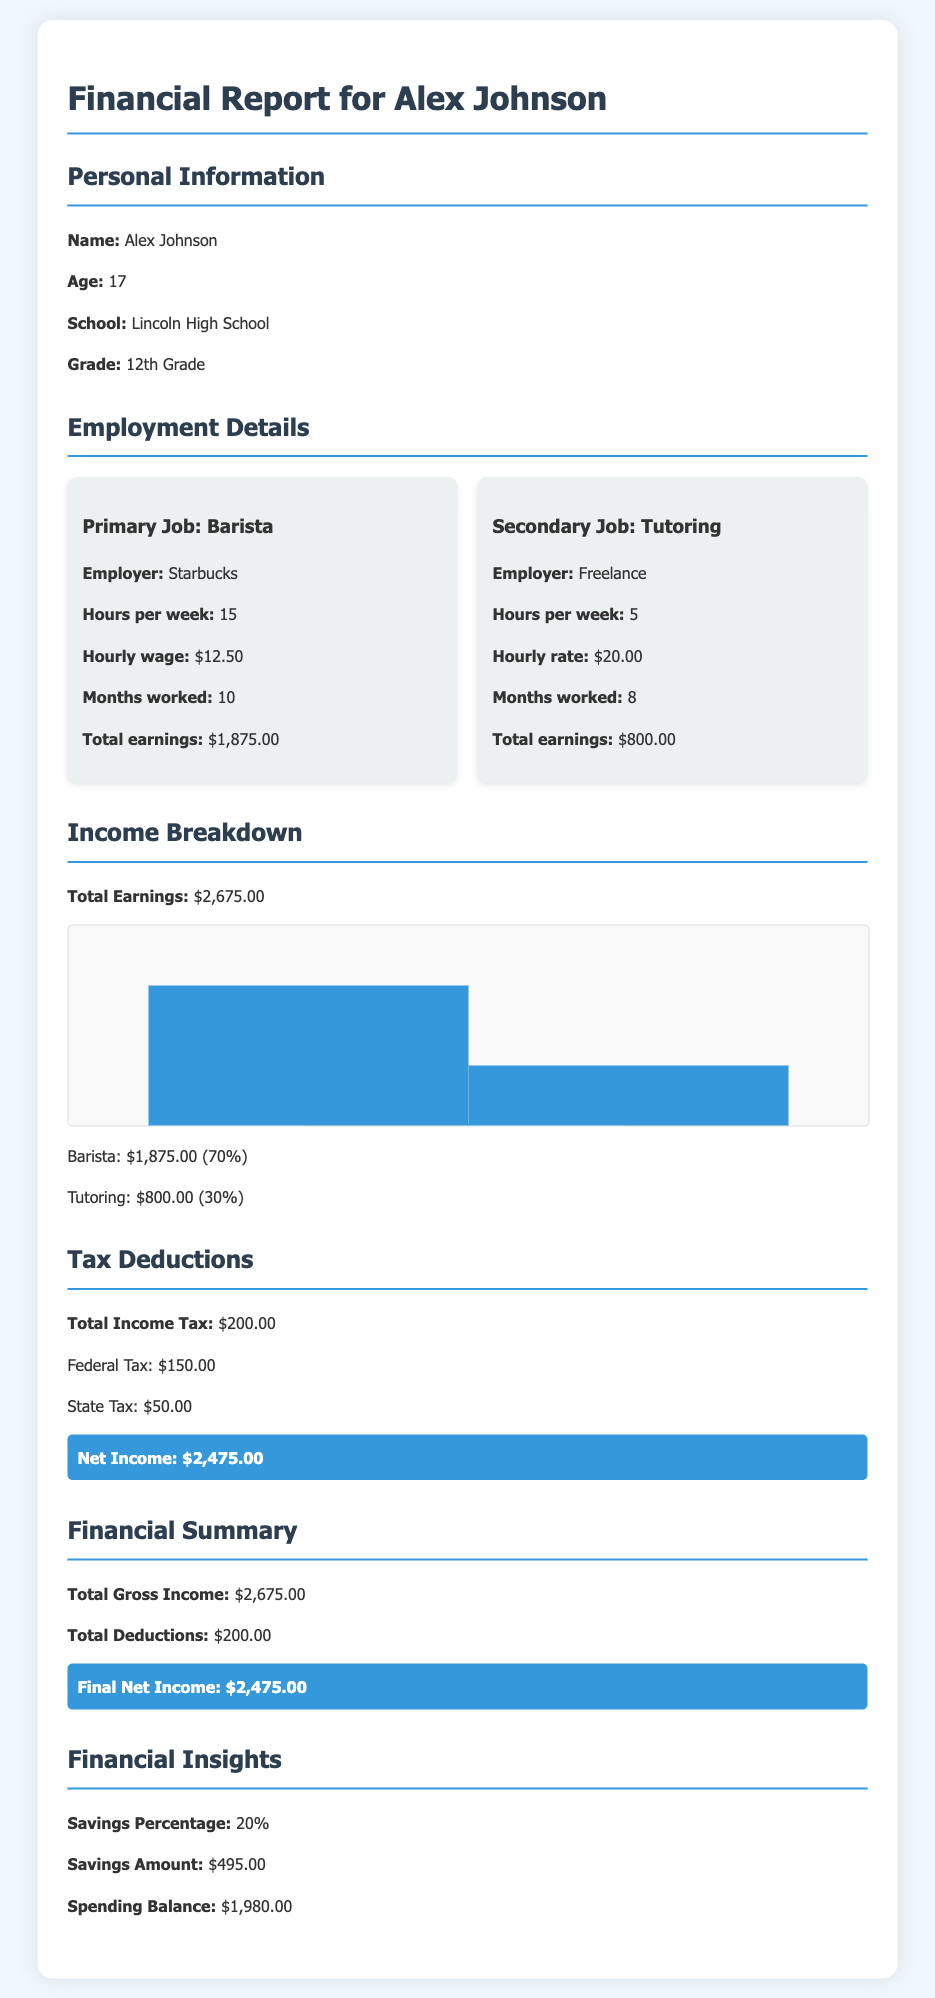What is the primary job? The primary job is identified in the document as "Barista" at Starbucks.
Answer: Barista What is the hourly wage for the primary job? The document states the hourly wage for the primary job is $12.50.
Answer: $12.50 How much did Alex earn from tutoring? The total earnings from tutoring are explicitly listed in the report as $800.00.
Answer: $800.00 What is the total income tax deducted? The total income tax is provided in the document as $200.00.
Answer: $200.00 What is the net income reported? The net income after tax deductions is highlighted in the document as $2,475.00.
Answer: $2,475.00 What percentage of total income is from the primary job? The report states that 70% of the total earnings come from the primary job, Barista.
Answer: 70% What is the total gross income? The document mentions that the total gross income is $2,675.00.
Answer: $2,675.00 How much does Alex plan to save? The document specifies that Alex plans to save $495.00.
Answer: $495.00 What is the spending balance after savings? The spending balance after savings is listed as $1,980.00 in the report.
Answer: $1,980.00 